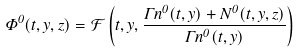Convert formula to latex. <formula><loc_0><loc_0><loc_500><loc_500>\Phi ^ { 0 } ( t , y , z ) = \mathcal { F } \left ( t , y , \frac { \Gamma n ^ { 0 } ( t , y ) + N ^ { 0 } ( t , y , z ) } { \Gamma n ^ { 0 } ( t , y ) } \right )</formula> 